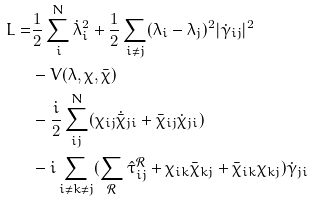<formula> <loc_0><loc_0><loc_500><loc_500>L = & \frac { 1 } { 2 } \sum _ { i } ^ { N } \dot { \lambda } ^ { 2 } _ { i } + \frac { 1 } { 2 } \sum _ { i \neq j } ( \lambda _ { i } - \lambda _ { j } ) ^ { 2 } | \dot { \gamma } _ { i j } | ^ { 2 } \\ & - V ( \lambda , \chi , \bar { \chi } ) \\ & - \frac { i } { 2 } \sum _ { i j } ^ { N } ( \chi _ { i j } \dot { \bar { \chi } } _ { j i } + \bar { \chi } _ { i j } \dot { \chi } _ { j i } ) \\ & - i \sum _ { i \neq k \neq j } ( \sum _ { \mathcal { R } } \hat { \tau } ^ { \mathcal { R } } _ { i j } + \chi _ { i k } \bar { \chi } _ { k j } + \bar { \chi } _ { i k } \chi _ { k j } ) \dot { \gamma } _ { j i }</formula> 